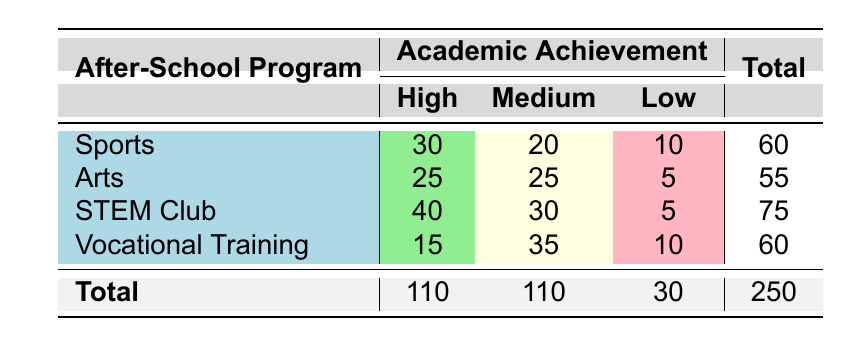What is the total number of students participating in Sports? To find the total number of students in the Sports program, I need to look at the last column in the row for Sports, which states 60.
Answer: 60 How many students in the STEM Club have a Low academic achievement? In the STEM Club row, there are 5 students listed under Low academic achievement.
Answer: 5 Which after-school program has the highest number of students with High academic achievement? By comparing the High column values for each program: Sports has 30, Arts has 25, STEM Club has 40, and Vocational Training has 15. The maximum is 40 from the STEM Club.
Answer: STEM Club What is the total number of students across all after-school programs with Medium academic achievement? Summing the Medium values: Sports (20) + Arts (25) + STEM Club (30) + Vocational Training (35) gives 20 + 25 + 30 + 35 = 110.
Answer: 110 Does the Arts program have more High academic achievement students than the Vocational Training program? Arts has 25 students with High achievement, while Vocational Training has 15. Since 25 is greater than 15, the statement is true.
Answer: Yes What is the average number of students with Low academic achievement across all programs? Adding the Low values gives 10 (Sports) + 5 (Arts) + 5 (STEM Club) + 10 (Vocational Training) = 30. There are 4 programs, so the average is 30 / 4 = 7.5.
Answer: 7.5 Which program has the lowest number of students overall? By checking the Total column, Sports has 60, Arts has 55, STEM Club has 75, and Vocational Training has 60. The lowest total is 55 from the Arts program.
Answer: Arts How many more students are in the STEM Club than in the Vocational Training program? The total for STEM Club is 75 and for Vocational Training is 60. The difference is 75 - 60 = 15.
Answer: 15 Is it true that the total number of students with High academic achievement is greater than those with Low academic achievement? The total for High is 110, and for Low it is 30. Since 110 is greater than 30, this statement is true.
Answer: Yes 